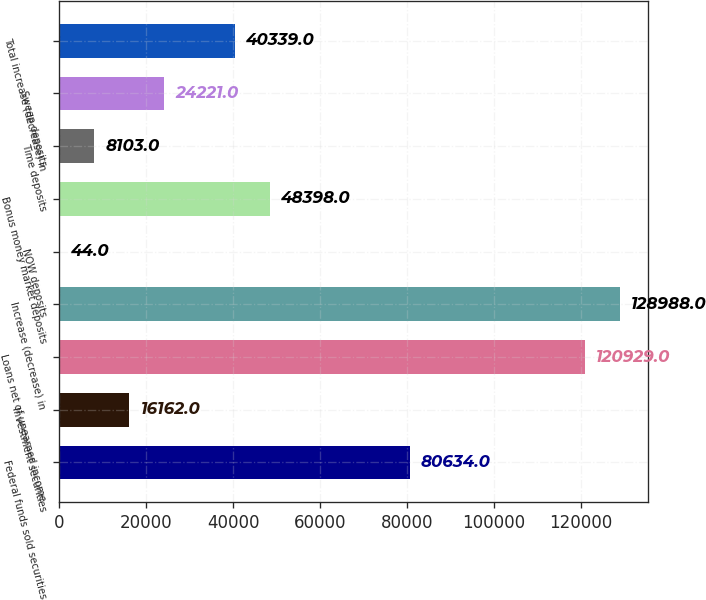<chart> <loc_0><loc_0><loc_500><loc_500><bar_chart><fcel>Federal funds sold securities<fcel>Investment securities<fcel>Loans net of unearned income<fcel>Increase (decrease) in<fcel>NOW deposits<fcel>Bonus money market deposits<fcel>Time deposits<fcel>Sweep deposits<fcel>Total increase (decrease) in<nl><fcel>80634<fcel>16162<fcel>120929<fcel>128988<fcel>44<fcel>48398<fcel>8103<fcel>24221<fcel>40339<nl></chart> 